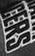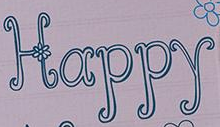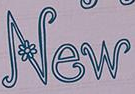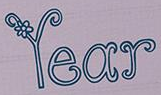Transcribe the words shown in these images in order, separated by a semicolon. CERS; Happy; New; Year 